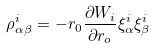Convert formula to latex. <formula><loc_0><loc_0><loc_500><loc_500>\rho ^ { i } _ { \alpha \beta } = - r _ { 0 } \frac { \partial W _ { i } } { \partial r _ { o } } \xi ^ { i } _ { \alpha } \xi ^ { i } _ { \beta }</formula> 